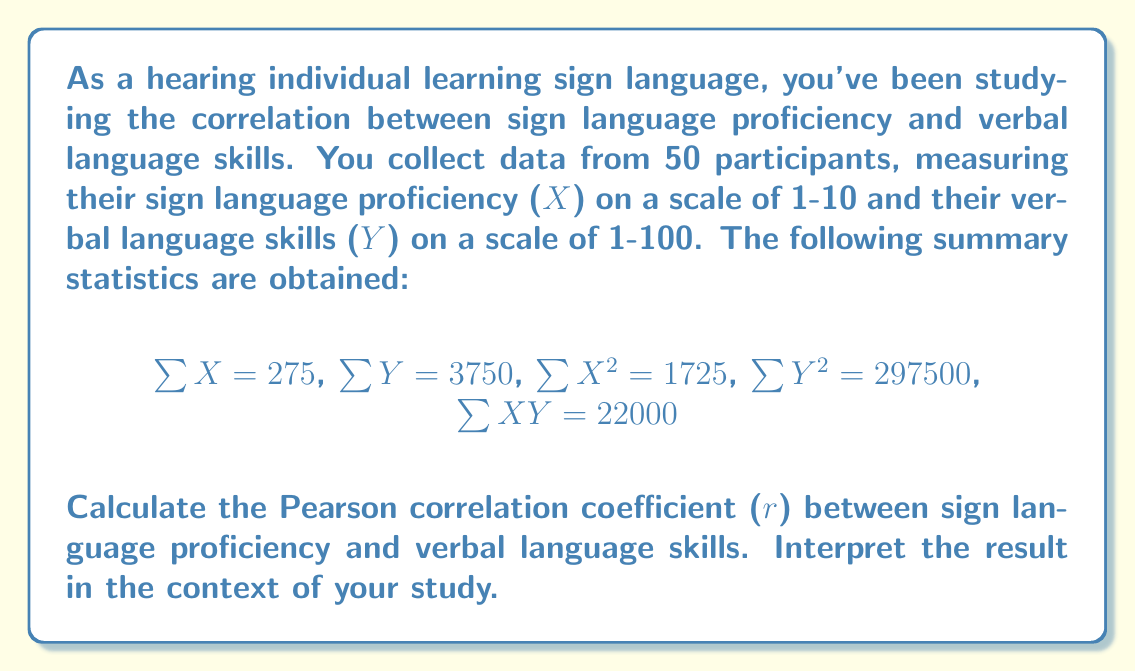Show me your answer to this math problem. To calculate the Pearson correlation coefficient (r), we'll use the formula:

$$r = \frac{n\sum XY - \sum X \sum Y}{\sqrt{[n\sum X^2 - (\sum X)^2][n\sum Y^2 - (\sum Y)^2]}}$$

Where n is the number of participants (50 in this case).

Let's calculate each component:

1. $n\sum XY = 50 \times 22000 = 1100000$
2. $\sum X \sum Y = 275 \times 3750 = 1031250$
3. $n\sum X^2 = 50 \times 1725 = 86250$
4. $(\sum X)^2 = 275^2 = 75625$
5. $n\sum Y^2 = 50 \times 297500 = 14875000$
6. $(\sum Y)^2 = 3750^2 = 14062500$

Now, let's substitute these values into the formula:

$$r = \frac{1100000 - 1031250}{\sqrt{(86250 - 75625)(14875000 - 14062500)}}$$

$$r = \frac{68750}{\sqrt{(10625)(812500)}}$$

$$r = \frac{68750}{\sqrt{8632812500}}$$

$$r = \frac{68750}{92912.41}$$

$$r \approx 0.74$$
Answer: The Pearson correlation coefficient (r) between sign language proficiency and verbal language skills is approximately 0.74. This indicates a strong positive correlation between the two variables. In the context of the study, this suggests that as sign language proficiency increases, verbal language skills tend to increase as well. This finding supports the idea that learning sign language may have positive effects on overall language skills for hearing individuals. 